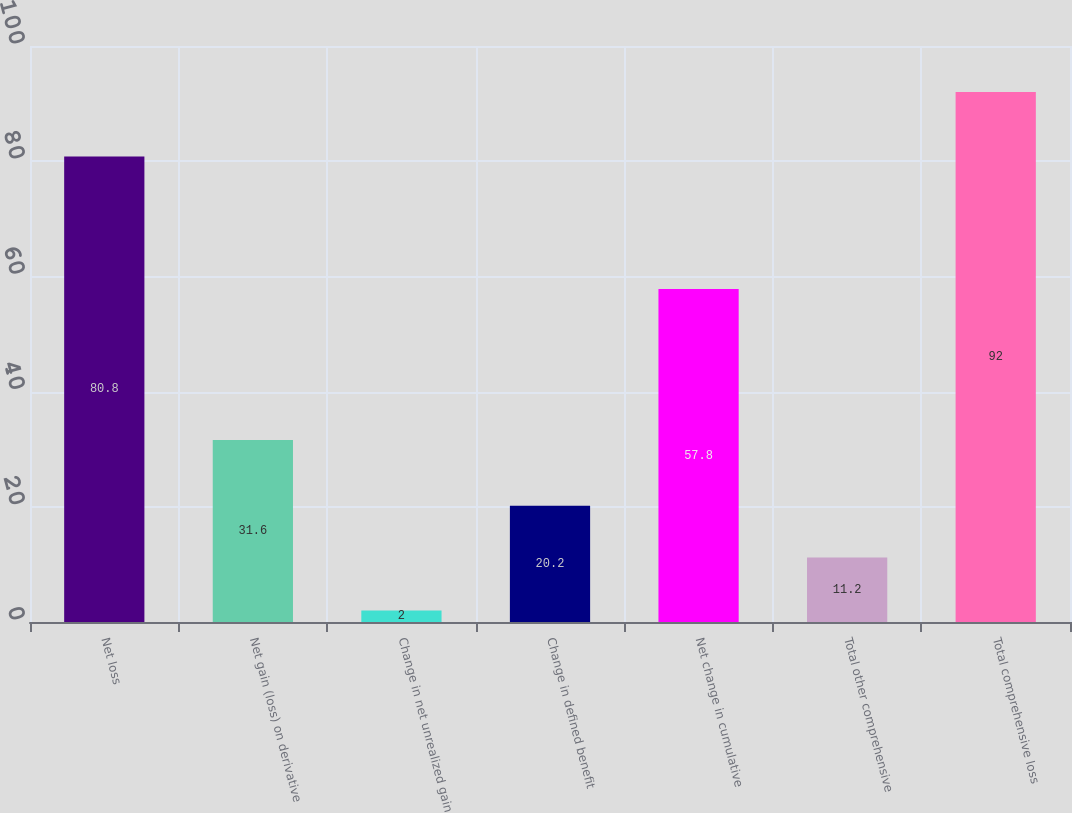Convert chart. <chart><loc_0><loc_0><loc_500><loc_500><bar_chart><fcel>Net loss<fcel>Net gain (loss) on derivative<fcel>Change in net unrealized gain<fcel>Change in defined benefit<fcel>Net change in cumulative<fcel>Total other comprehensive<fcel>Total comprehensive loss<nl><fcel>80.8<fcel>31.6<fcel>2<fcel>20.2<fcel>57.8<fcel>11.2<fcel>92<nl></chart> 